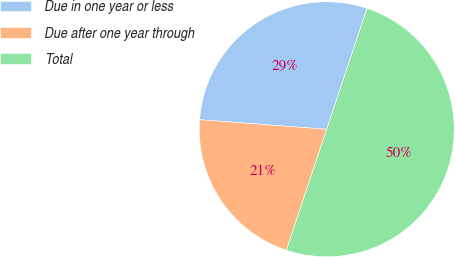<chart> <loc_0><loc_0><loc_500><loc_500><pie_chart><fcel>Due in one year or less<fcel>Due after one year through<fcel>Total<nl><fcel>28.93%<fcel>21.07%<fcel>50.0%<nl></chart> 